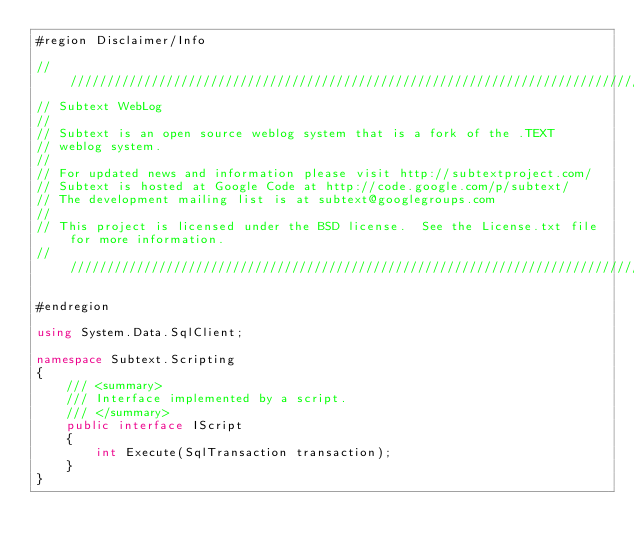Convert code to text. <code><loc_0><loc_0><loc_500><loc_500><_C#_>#region Disclaimer/Info

///////////////////////////////////////////////////////////////////////////////////////////////////
// Subtext WebLog
// 
// Subtext is an open source weblog system that is a fork of the .TEXT
// weblog system.
//
// For updated news and information please visit http://subtextproject.com/
// Subtext is hosted at Google Code at http://code.google.com/p/subtext/
// The development mailing list is at subtext@googlegroups.com 
//
// This project is licensed under the BSD license.  See the License.txt file for more information.
///////////////////////////////////////////////////////////////////////////////////////////////////

#endregion

using System.Data.SqlClient;

namespace Subtext.Scripting
{
    /// <summary>
    /// Interface implemented by a script.
    /// </summary>
    public interface IScript
    {
        int Execute(SqlTransaction transaction);
    }
}</code> 